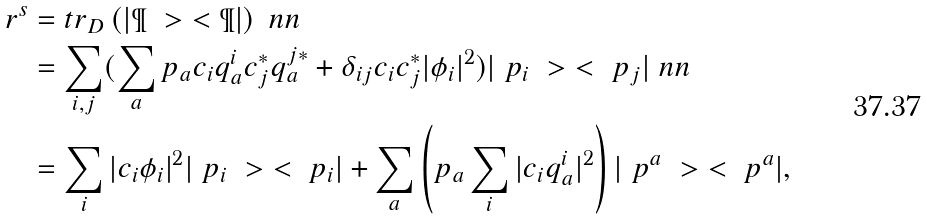Convert formula to latex. <formula><loc_0><loc_0><loc_500><loc_500>\ r ^ { s } & = t r _ { D } \left ( | \P \ > \ < \P | \right ) \ n n \\ & = \sum _ { i , j } ( \sum _ { a } p _ { a } c _ { i } q ^ { i } _ { a } c ^ { * } _ { j } q ^ { j * } _ { a } + \delta _ { i j } c _ { i } c _ { j } ^ { * } | \phi _ { i } | ^ { 2 } ) | \ p _ { i } \ > \ < \ p _ { j } | \ n n \\ & = \sum _ { i } | c _ { i } \phi _ { i } | ^ { 2 } | \ p _ { i } \ > \ < \ p _ { i } | + \sum _ { a } \left ( p _ { a } \sum _ { i } | c _ { i } q _ { a } ^ { i } | ^ { 2 } \right ) | \ p ^ { a } \ > \ < \ p ^ { a } | ,</formula> 